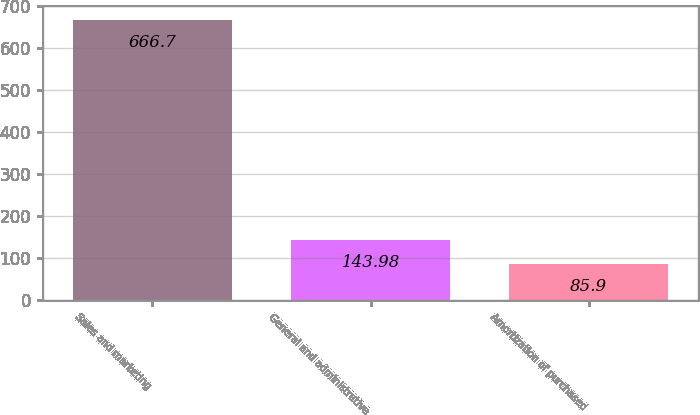Convert chart to OTSL. <chart><loc_0><loc_0><loc_500><loc_500><bar_chart><fcel>Sales and marketing<fcel>General and administrative<fcel>Amortization of purchased<nl><fcel>666.7<fcel>143.98<fcel>85.9<nl></chart> 